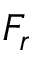Convert formula to latex. <formula><loc_0><loc_0><loc_500><loc_500>F _ { r }</formula> 